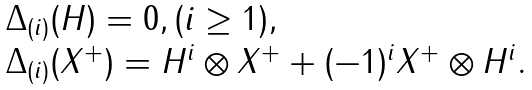Convert formula to latex. <formula><loc_0><loc_0><loc_500><loc_500>\begin{array} { r c l } & & \Delta _ { ( i ) } ( H ) = 0 , ( i \geq 1 ) , \\ & & \Delta _ { ( i ) } ( X ^ { + } ) = H ^ { i } \otimes X ^ { + } + ( - 1 ) ^ { i } X ^ { + } \otimes H ^ { i } . \end{array}</formula> 